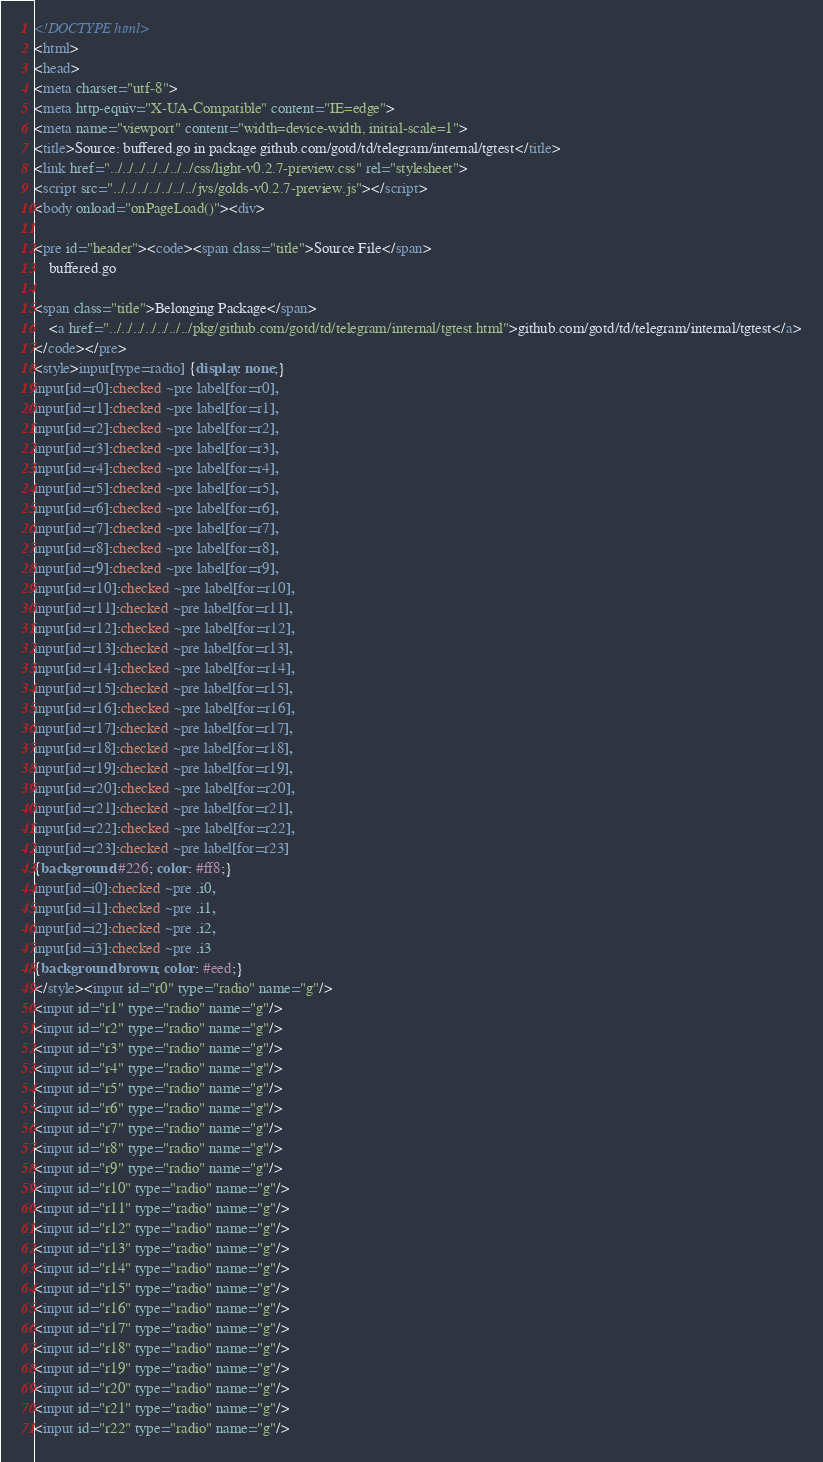Convert code to text. <code><loc_0><loc_0><loc_500><loc_500><_HTML_><!DOCTYPE html>
<html>
<head>
<meta charset="utf-8">
<meta http-equiv="X-UA-Compatible" content="IE=edge">
<meta name="viewport" content="width=device-width, initial-scale=1">
<title>Source: buffered.go in package github.com/gotd/td/telegram/internal/tgtest</title>
<link href="../../../../../../../css/light-v0.2.7-preview.css" rel="stylesheet">
<script src="../../../../../../../jvs/golds-v0.2.7-preview.js"></script>
<body onload="onPageLoad()"><div>

<pre id="header"><code><span class="title">Source File</span>
	buffered.go

<span class="title">Belonging Package</span>
	<a href="../../../../../../../pkg/github.com/gotd/td/telegram/internal/tgtest.html">github.com/gotd/td/telegram/internal/tgtest</a>
</code></pre>
<style>input[type=radio] {display: none;}
input[id=r0]:checked ~pre label[for=r0],
input[id=r1]:checked ~pre label[for=r1],
input[id=r2]:checked ~pre label[for=r2],
input[id=r3]:checked ~pre label[for=r3],
input[id=r4]:checked ~pre label[for=r4],
input[id=r5]:checked ~pre label[for=r5],
input[id=r6]:checked ~pre label[for=r6],
input[id=r7]:checked ~pre label[for=r7],
input[id=r8]:checked ~pre label[for=r8],
input[id=r9]:checked ~pre label[for=r9],
input[id=r10]:checked ~pre label[for=r10],
input[id=r11]:checked ~pre label[for=r11],
input[id=r12]:checked ~pre label[for=r12],
input[id=r13]:checked ~pre label[for=r13],
input[id=r14]:checked ~pre label[for=r14],
input[id=r15]:checked ~pre label[for=r15],
input[id=r16]:checked ~pre label[for=r16],
input[id=r17]:checked ~pre label[for=r17],
input[id=r18]:checked ~pre label[for=r18],
input[id=r19]:checked ~pre label[for=r19],
input[id=r20]:checked ~pre label[for=r20],
input[id=r21]:checked ~pre label[for=r21],
input[id=r22]:checked ~pre label[for=r22],
input[id=r23]:checked ~pre label[for=r23]
{background: #226; color: #ff8;}
input[id=i0]:checked ~pre .i0,
input[id=i1]:checked ~pre .i1,
input[id=i2]:checked ~pre .i2,
input[id=i3]:checked ~pre .i3
{background: brown; color: #eed;}
</style><input id="r0" type="radio" name="g"/>
<input id="r1" type="radio" name="g"/>
<input id="r2" type="radio" name="g"/>
<input id="r3" type="radio" name="g"/>
<input id="r4" type="radio" name="g"/>
<input id="r5" type="radio" name="g"/>
<input id="r6" type="radio" name="g"/>
<input id="r7" type="radio" name="g"/>
<input id="r8" type="radio" name="g"/>
<input id="r9" type="radio" name="g"/>
<input id="r10" type="radio" name="g"/>
<input id="r11" type="radio" name="g"/>
<input id="r12" type="radio" name="g"/>
<input id="r13" type="radio" name="g"/>
<input id="r14" type="radio" name="g"/>
<input id="r15" type="radio" name="g"/>
<input id="r16" type="radio" name="g"/>
<input id="r17" type="radio" name="g"/>
<input id="r18" type="radio" name="g"/>
<input id="r19" type="radio" name="g"/>
<input id="r20" type="radio" name="g"/>
<input id="r21" type="radio" name="g"/>
<input id="r22" type="radio" name="g"/></code> 